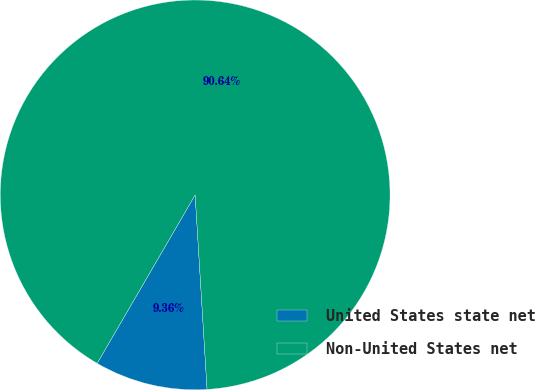Convert chart to OTSL. <chart><loc_0><loc_0><loc_500><loc_500><pie_chart><fcel>United States state net<fcel>Non-United States net<nl><fcel>9.36%<fcel>90.64%<nl></chart> 